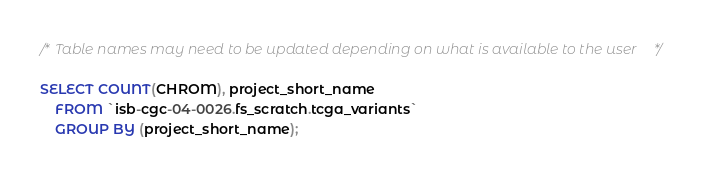Convert code to text. <code><loc_0><loc_0><loc_500><loc_500><_SQL_>/* Table names may need to be updated depending on what is available to the user */

SELECT COUNT(CHROM), project_short_name
    FROM `isb-cgc-04-0026.fs_scratch.tcga_variants`
    GROUP BY (project_short_name);
</code> 